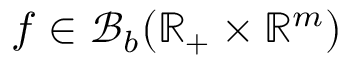Convert formula to latex. <formula><loc_0><loc_0><loc_500><loc_500>f \in \mathcal { B } _ { b } ( \mathbb { R } _ { + } \times \mathbb { R } ^ { m } )</formula> 